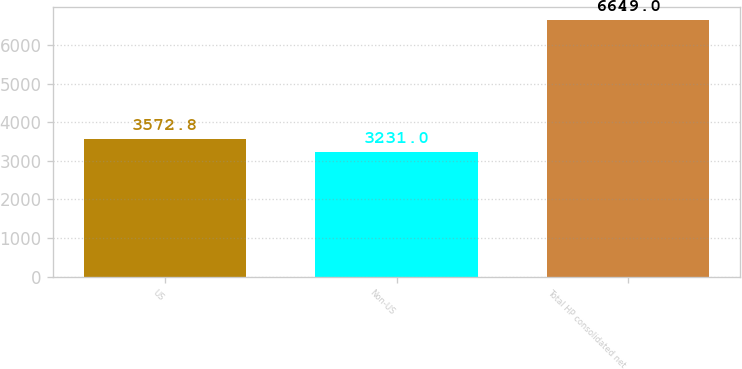Convert chart to OTSL. <chart><loc_0><loc_0><loc_500><loc_500><bar_chart><fcel>US<fcel>Non-US<fcel>Total HP consolidated net<nl><fcel>3572.8<fcel>3231<fcel>6649<nl></chart> 